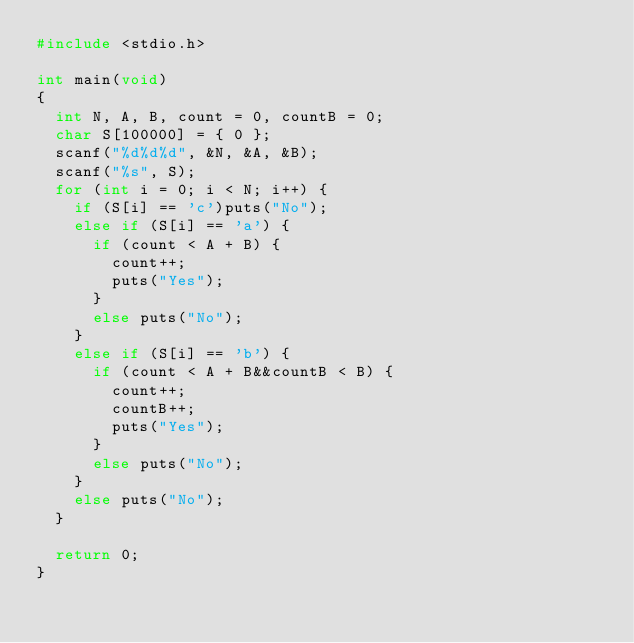<code> <loc_0><loc_0><loc_500><loc_500><_C_>#include <stdio.h>

int main(void)
{
	int N, A, B, count = 0, countB = 0;
	char S[100000] = { 0 };
	scanf("%d%d%d", &N, &A, &B);
	scanf("%s", S);
	for (int i = 0; i < N; i++) {
		if (S[i] == 'c')puts("No");
		else if (S[i] == 'a') {
			if (count < A + B) {
				count++;
				puts("Yes");
			}
			else puts("No");
		}
		else if (S[i] == 'b') {
			if (count < A + B&&countB < B) {
				count++;
				countB++;
				puts("Yes");
			}
			else puts("No");
		}
		else puts("No");
	}

	return 0;
}</code> 